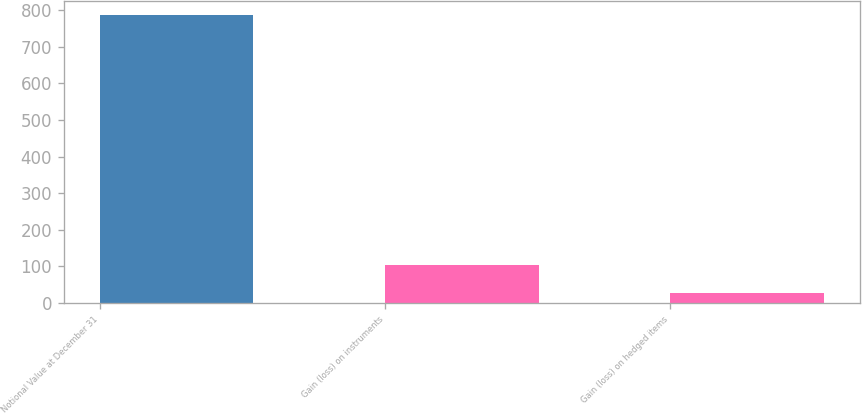Convert chart to OTSL. <chart><loc_0><loc_0><loc_500><loc_500><bar_chart><fcel>Notional Value at December 31<fcel>Gain (loss) on instruments<fcel>Gain (loss) on hedged items<nl><fcel>785<fcel>102.8<fcel>27<nl></chart> 